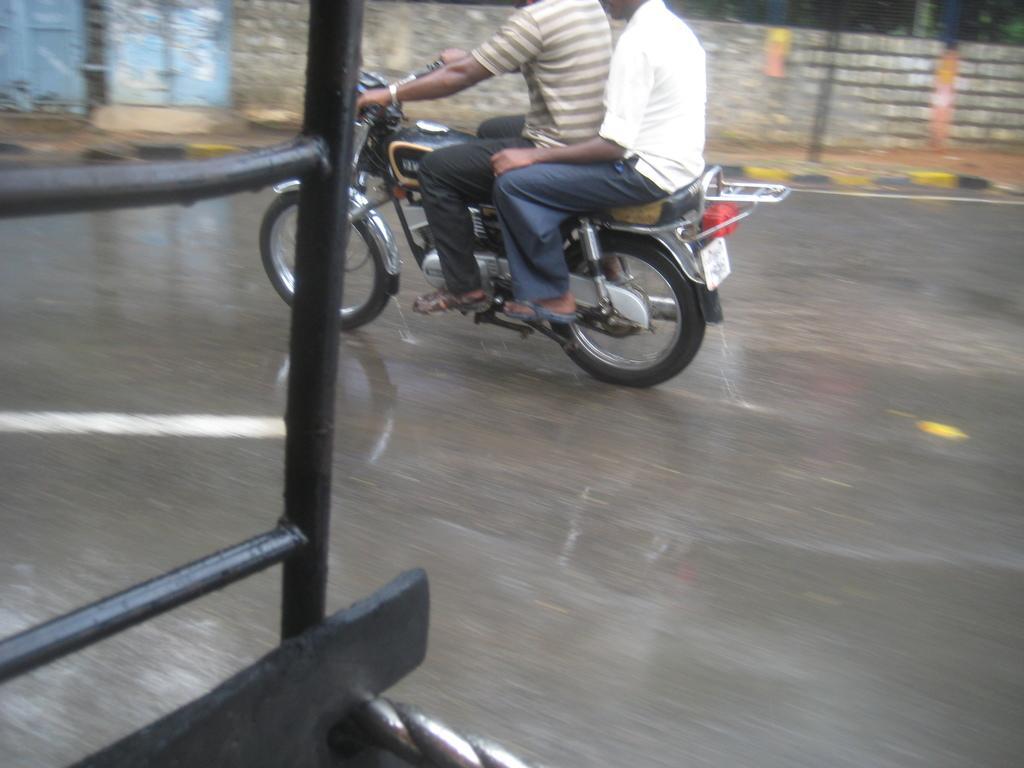How would you summarize this image in a sentence or two? Here we can see the two persons on motorcycle and travelling on the road, and here is the wall. 